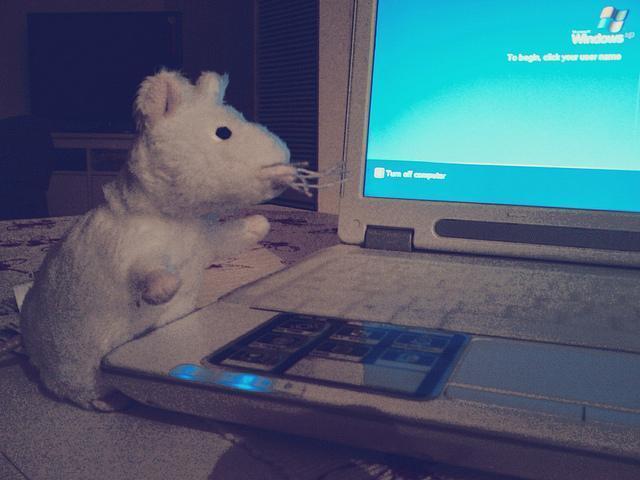How many tvs are in the picture?
Give a very brief answer. 1. 